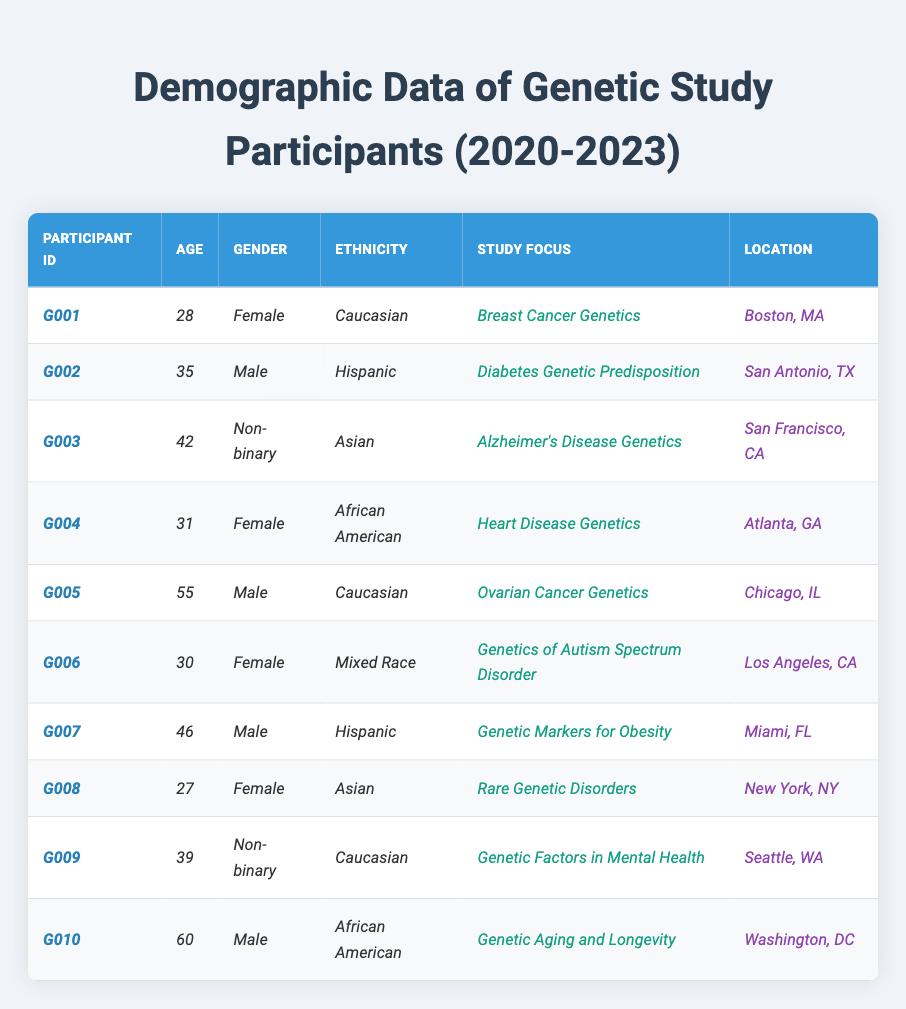What is the age of participant G003? Participant G003 is listed in the table, and under the 'Age' column, the value corresponding to this participant is 42.
Answer: 42 How many female participants are in the study? To find the number of female participants, we can scan through the 'Gender' column in the table. There are four females listed: G001, G004, G006, and G008.
Answer: 4 Which study focus has the participant with the highest age? The participant with the highest age is G010, who is 60 years old. Looking at the table, their study focus is "Genetic Aging and Longevity."
Answer: Genetic Aging and Longevity Is there any participant identified as Non-binary? Scanning the table shows there are two participants identified as Non-binary: G003 and G009. Therefore, the answer is yes.
Answer: Yes What is the average age of male participants? The male participants are G002, G005, G007, and G010. Their ages are 35, 55, 46, and 60. Summing these gives 35 + 55 + 46 + 60 = 196. Dividing by 4 (the number of male participants) gives an average age of 196/4 = 49.
Answer: 49 In which location is the participant focused on Rare Genetic Disorders? The participant studying Rare Genetic Disorders is G008, listed under the 'Location' column as New York, NY.
Answer: New York, NY What ethnicity is most common among the participants? By reviewing the 'Ethnicity' column, we see Caucasian appears 3 times (G001, G005, G009), Hispanic appears 2 times (G002, G007), and other ethnicities count once. Therefore, Caucasian is the most common ethnicity.
Answer: Caucasian How many participants are located in California? The locations of the participants are Los Angeles, CA (G006), San Francisco, CA (G003), and New York, NY (G008). Therefore, there are 2 participants in California (G006 and G003).
Answer: 2 What percentage of participants are Male or Non-binary? There are 4 male participants (G002, G005, G007, G010) and 2 Non-binary participants (G003, G009), making 6 out of 10 participants. Hence, the percentage is (6/10) * 100 = 60%.
Answer: 60% What is the total number of participants focusing on cancer genetics? Reviewing the 'Study Focus' column, there are 3 participants focused on cancer genetics: G001 (Breast Cancer Genetics), G005 (Ovarian Cancer Genetics), and G004 (Heart Disease Genetics). Therefore, the total is 3 participants.
Answer: 3 What type of study focus is associated with the youngest participant? The youngest participant is G008 with an age of 27. Their study focus is "Rare Genetic Disorders."
Answer: Rare Genetic Disorders 